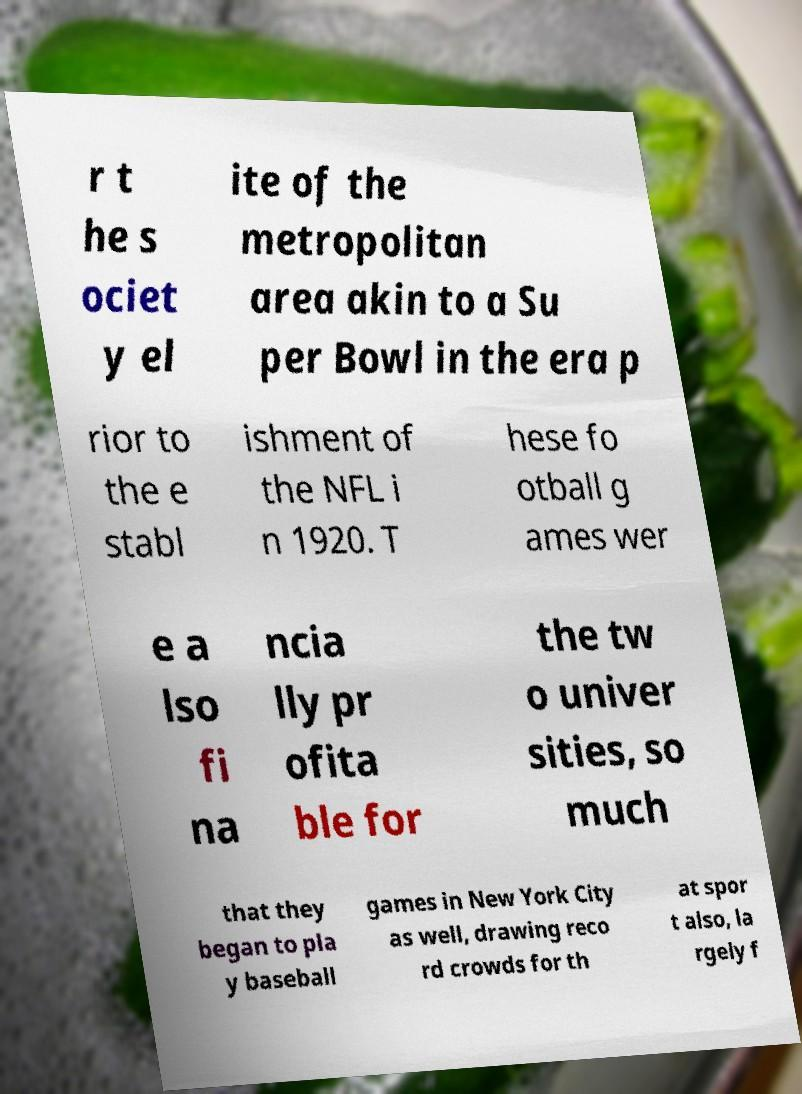Can you accurately transcribe the text from the provided image for me? r t he s ociet y el ite of the metropolitan area akin to a Su per Bowl in the era p rior to the e stabl ishment of the NFL i n 1920. T hese fo otball g ames wer e a lso fi na ncia lly pr ofita ble for the tw o univer sities, so much that they began to pla y baseball games in New York City as well, drawing reco rd crowds for th at spor t also, la rgely f 